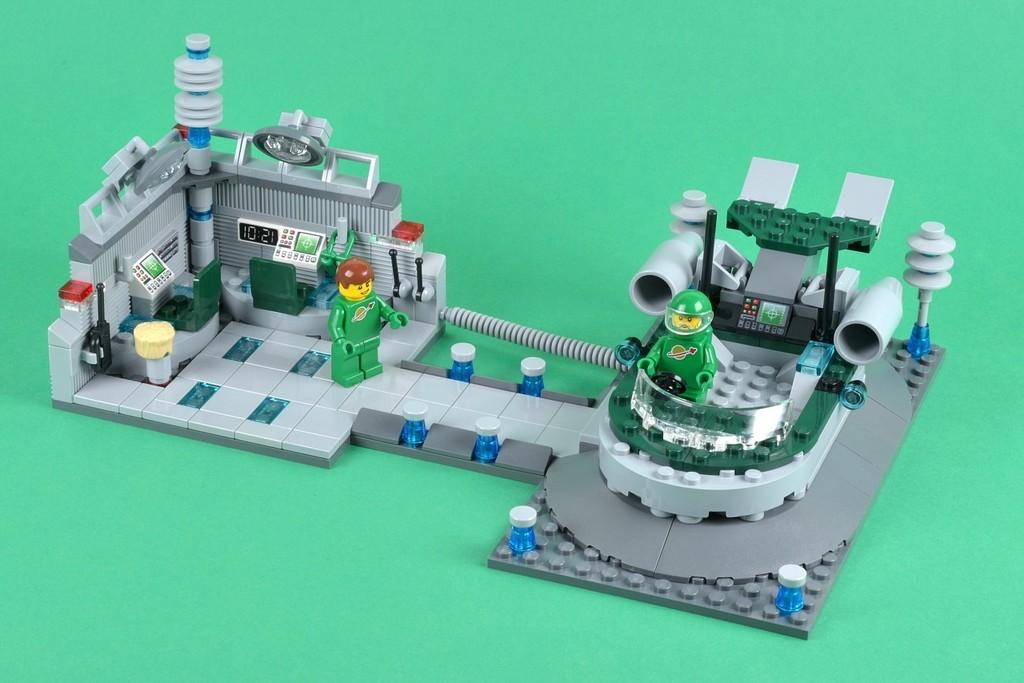What objects are present on the floor in the image? There are toys on the floor in the image. What is the color of the floor? The floor is green in color. Can you see any waves crashing on the shore in the image? There are no waves or shore visible in the image; it features toys on a green floor. 